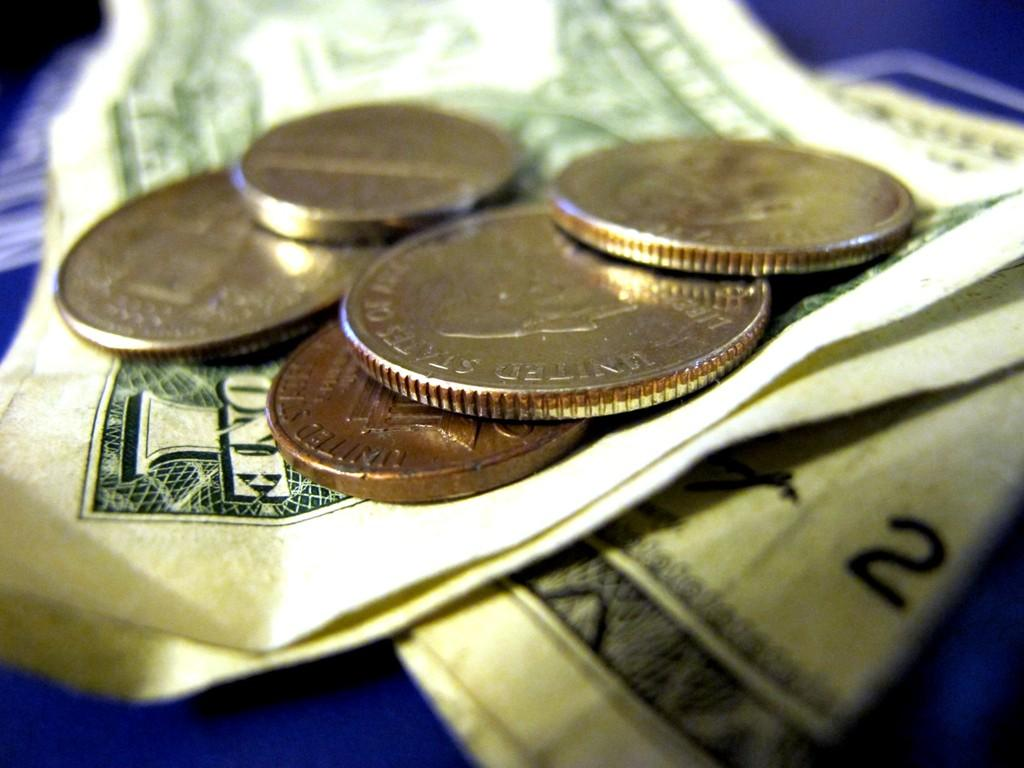<image>
Share a concise interpretation of the image provided. coins on top of a one dollar bill that say 'united states of america' 